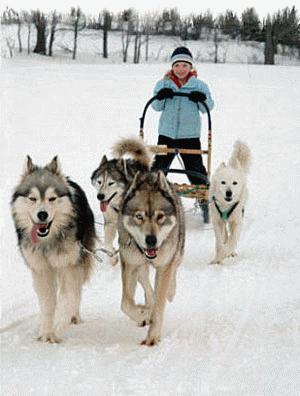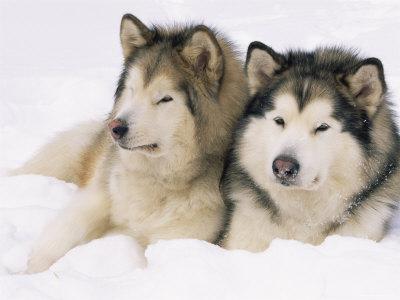The first image is the image on the left, the second image is the image on the right. Assess this claim about the two images: "There are at most three dogs in total.". Correct or not? Answer yes or no. No. The first image is the image on the left, the second image is the image on the right. For the images displayed, is the sentence "One of the images contains exactly two dogs." factually correct? Answer yes or no. Yes. 